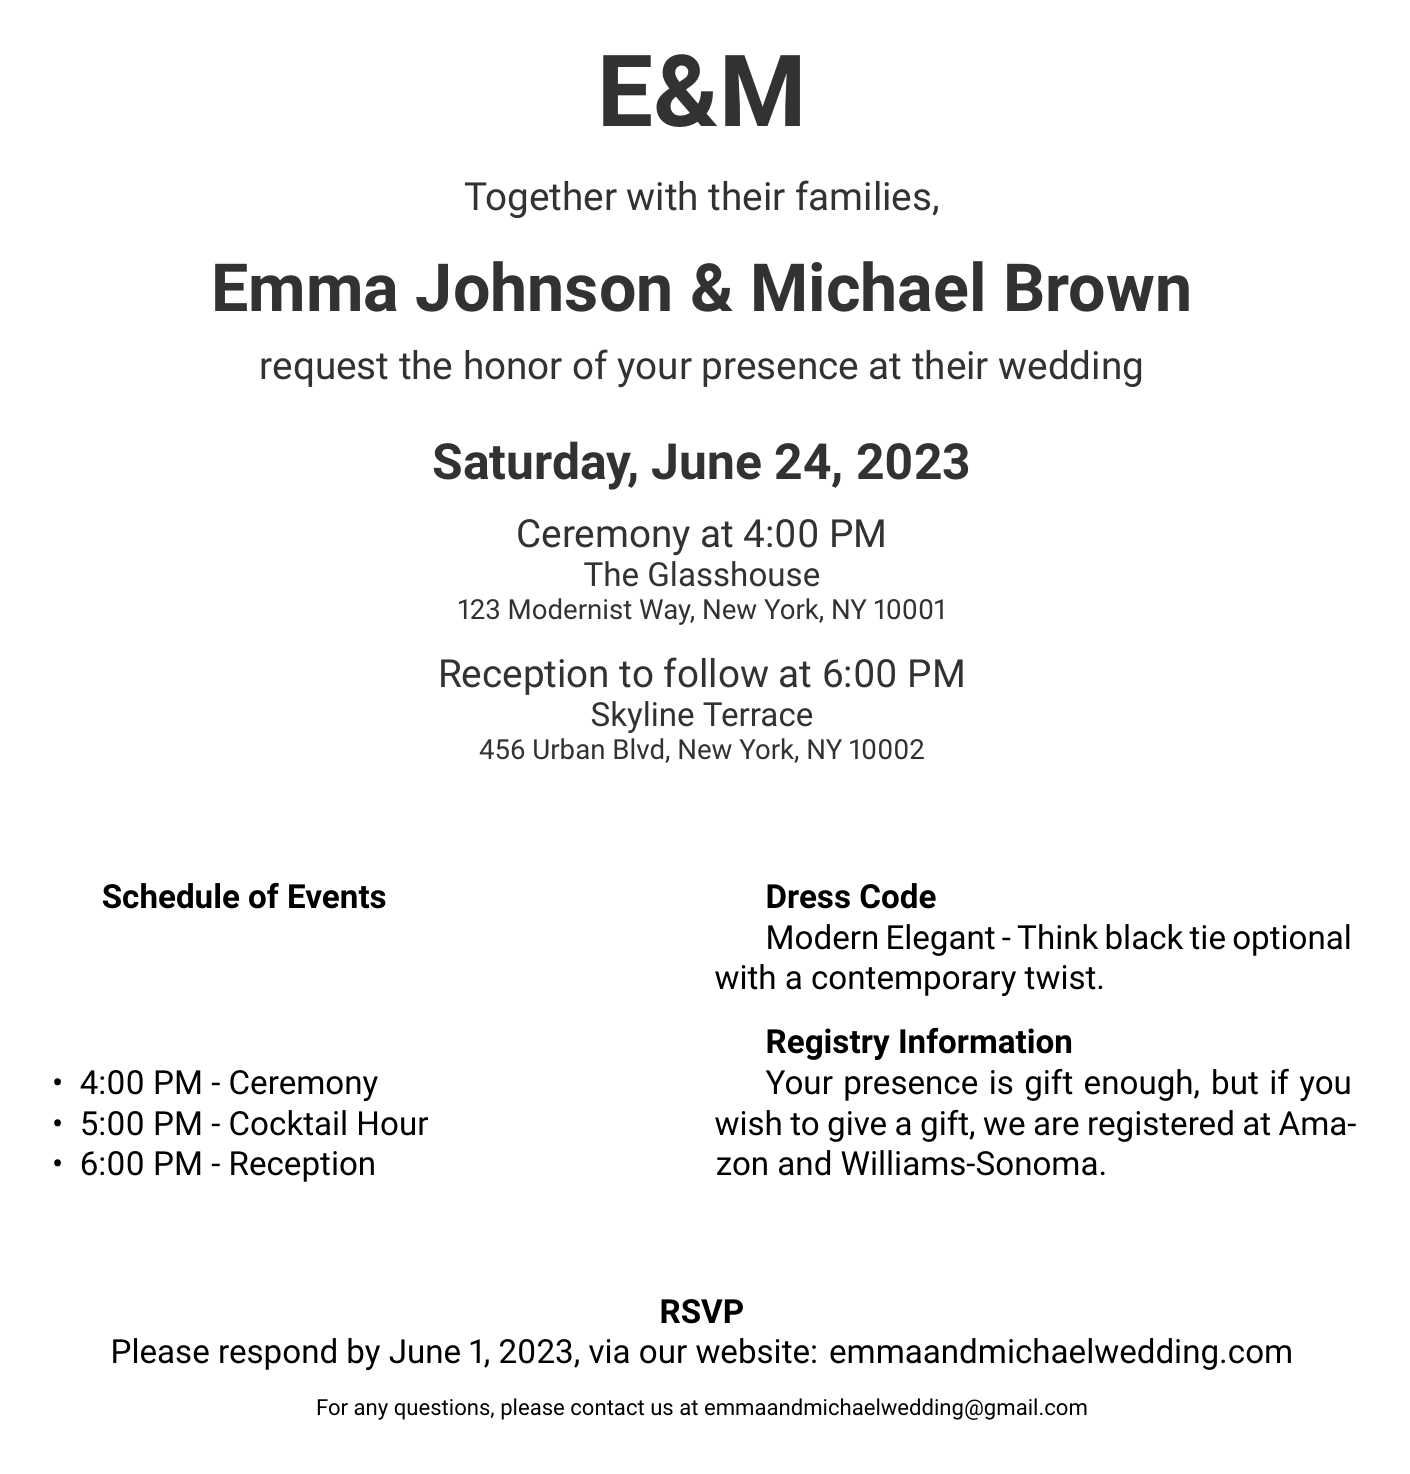What are the names of the couple? The couple’s names are listed prominently at the top of the invitation.
Answer: Emma Johnson & Michael Brown What is the date of the wedding? The date is highlighted on the invitation and is essential for the event.
Answer: Saturday, June 24, 2023 What time does the ceremony start? The time for the ceremony is stated clearly in the schedule of events.
Answer: 4:00 PM Where is the ceremony taking place? The venue for the ceremony is specified in the document.
Answer: The Glasshouse What is the dress code? The dress code is mentioned explicitly in the invitation details.
Answer: Modern Elegant What should guests do if they have questions? Contact information is provided for guests needing assistance.
Answer: emmaandmichaelwedding@gmail.com What is the deadline for RSVPs? The RSVP deadline is clearly stated in the invitation.
Answer: June 1, 2023 Where can guests respond to the invitation? The method of response is listed for convenience.
Answer: emmaandmichaelwedding.com What is the location of the reception? The reception venue is given in the invitation and is an important detail.
Answer: Skyline Terrace 